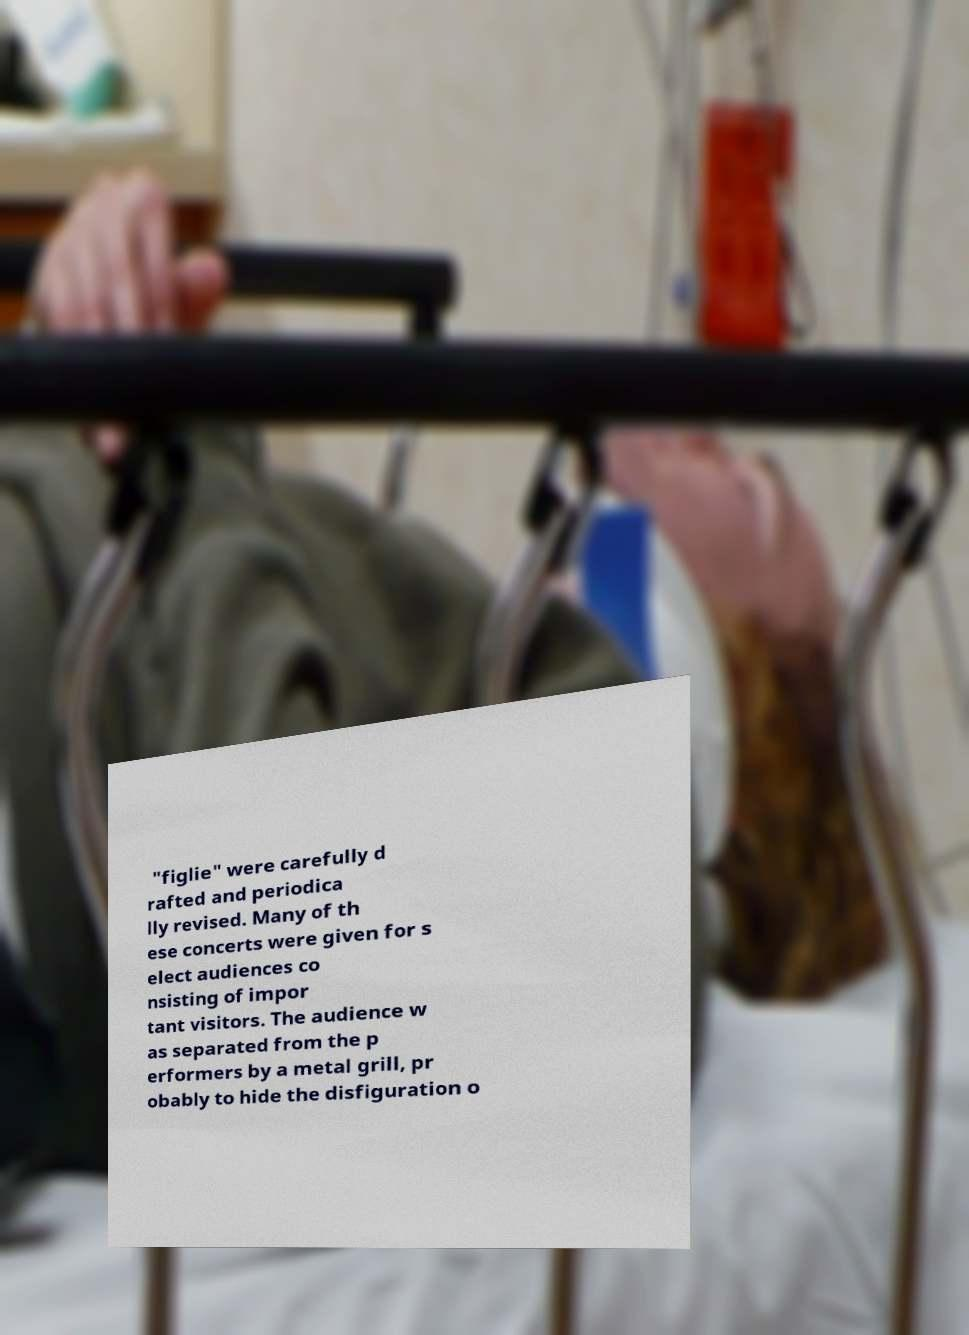There's text embedded in this image that I need extracted. Can you transcribe it verbatim? "figlie" were carefully d rafted and periodica lly revised. Many of th ese concerts were given for s elect audiences co nsisting of impor tant visitors. The audience w as separated from the p erformers by a metal grill, pr obably to hide the disfiguration o 